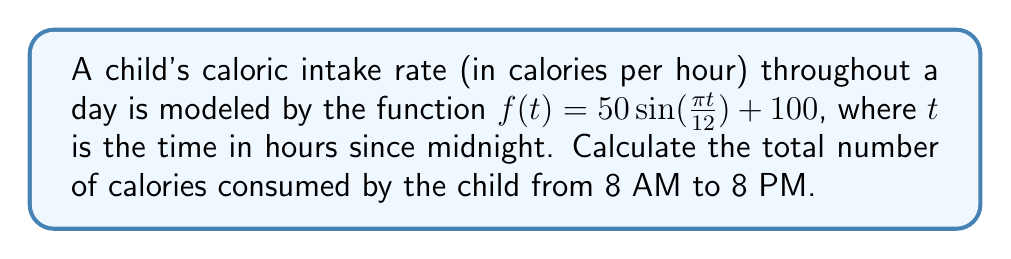Solve this math problem. To solve this problem, we need to integrate the caloric intake rate function over the given time period. Let's approach this step-by-step:

1) First, we need to set up the integral. The time period is from 8 AM to 8 PM, which in our model corresponds to $t=8$ to $t=20$.

   $$\int_{8}^{20} (50 \sin(\frac{\pi t}{12}) + 100) dt$$

2) We can split this into two integrals:

   $$50\int_{8}^{20} \sin(\frac{\pi t}{12}) dt + 100\int_{8}^{20} dt$$

3) Let's solve the second integral first, as it's simpler:

   $$100\int_{8}^{20} dt = 100t \Big|_{8}^{20} = 100(20-8) = 1200$$

4) For the first integral, we need to use substitution. Let $u = \frac{\pi t}{12}$, then $du = \frac{\pi}{12} dt$ or $dt = \frac{12}{\pi} du$

   $$50\int_{8}^{20} \sin(\frac{\pi t}{12}) dt = 50 \cdot \frac{12}{\pi} \int_{\frac{2\pi}{3}}^{\frac{5\pi}{3}} \sin(u) du$$

5) Now we can integrate:

   $$\frac{600}{\pi} [-\cos(u)] \Big|_{\frac{2\pi}{3}}^{\frac{5\pi}{3}}$$

6) Evaluate:

   $$\frac{600}{\pi} [-\cos(\frac{5\pi}{3}) + \cos(\frac{2\pi}{3})]$$
   $$= \frac{600}{\pi} [-(-\frac{1}{2}) + (-\frac{1}{2})] = 0$$

7) Adding the results from steps 3 and 6:

   $$1200 + 0 = 1200$$

Therefore, the total number of calories consumed from 8 AM to 8 PM is 1200 calories.
Answer: 1200 calories 